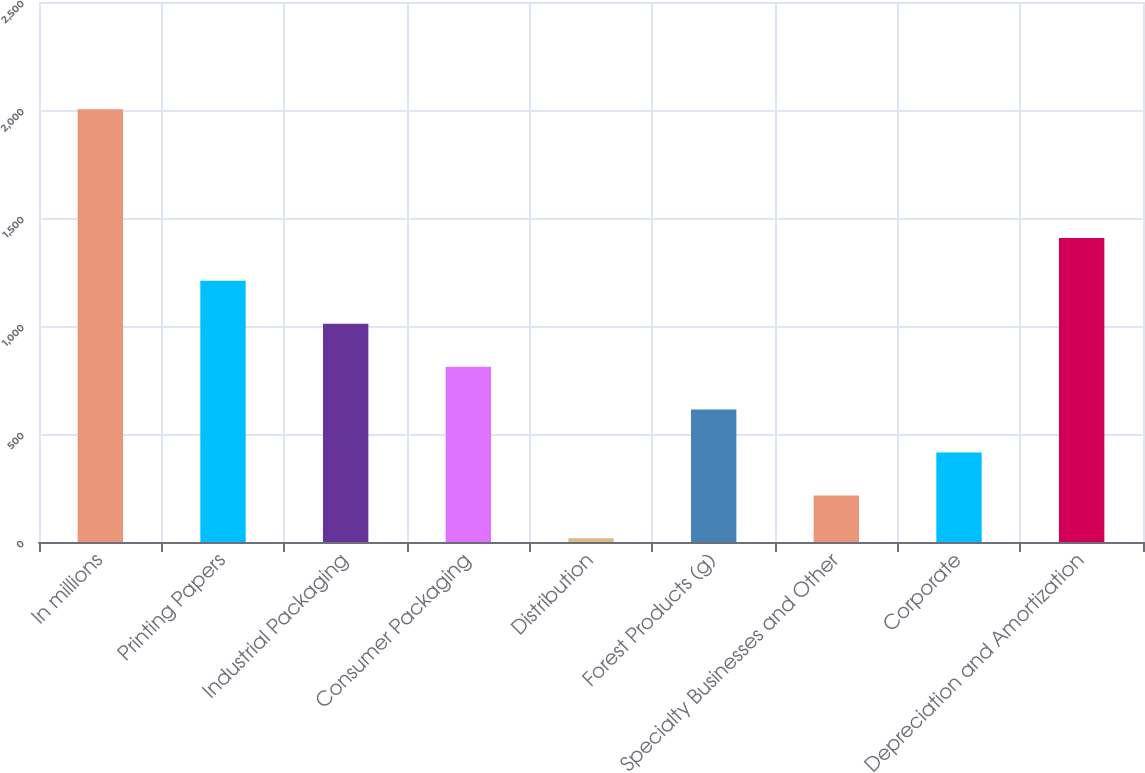Convert chart. <chart><loc_0><loc_0><loc_500><loc_500><bar_chart><fcel>In millions<fcel>Printing Papers<fcel>Industrial Packaging<fcel>Consumer Packaging<fcel>Distribution<fcel>Forest Products (g)<fcel>Specialty Businesses and Other<fcel>Corporate<fcel>Depreciation and Amortization<nl><fcel>2004<fcel>1209.2<fcel>1010.5<fcel>811.8<fcel>17<fcel>613.1<fcel>215.7<fcel>414.4<fcel>1407.9<nl></chart> 